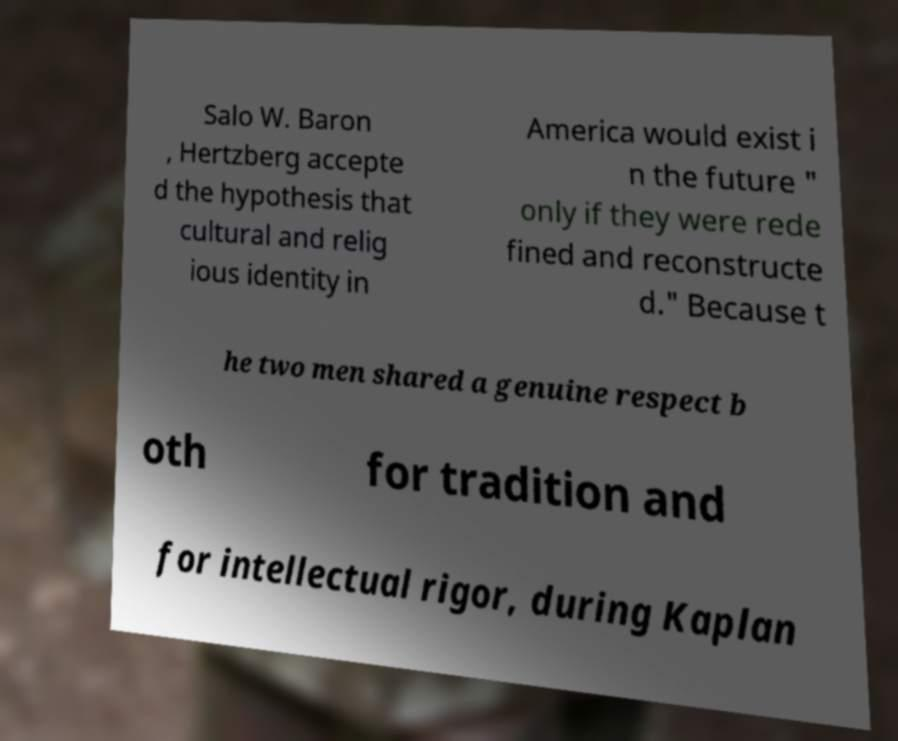Can you accurately transcribe the text from the provided image for me? Salo W. Baron , Hertzberg accepte d the hypothesis that cultural and relig ious identity in America would exist i n the future " only if they were rede fined and reconstructe d." Because t he two men shared a genuine respect b oth for tradition and for intellectual rigor, during Kaplan 